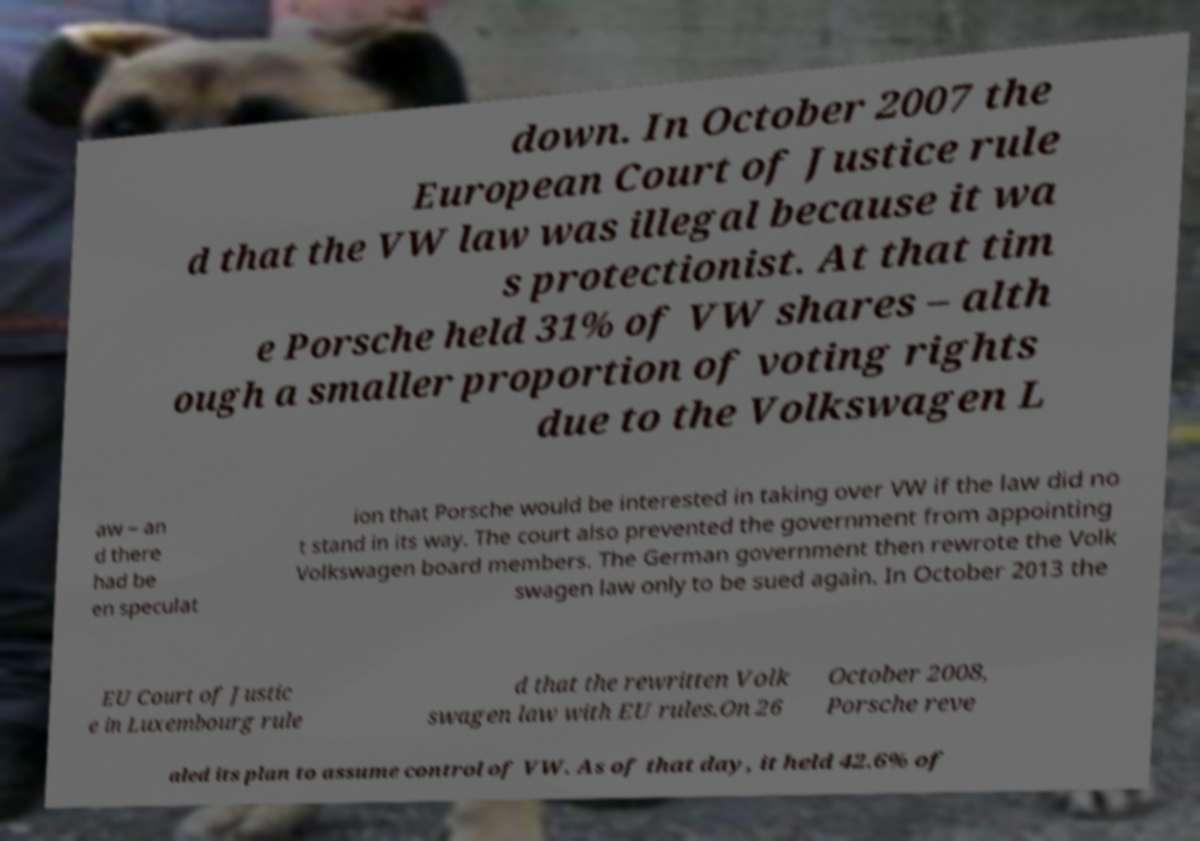Please read and relay the text visible in this image. What does it say? down. In October 2007 the European Court of Justice rule d that the VW law was illegal because it wa s protectionist. At that tim e Porsche held 31% of VW shares – alth ough a smaller proportion of voting rights due to the Volkswagen L aw – an d there had be en speculat ion that Porsche would be interested in taking over VW if the law did no t stand in its way. The court also prevented the government from appointing Volkswagen board members. The German government then rewrote the Volk swagen law only to be sued again. In October 2013 the EU Court of Justic e in Luxembourg rule d that the rewritten Volk swagen law with EU rules.On 26 October 2008, Porsche reve aled its plan to assume control of VW. As of that day, it held 42.6% of 